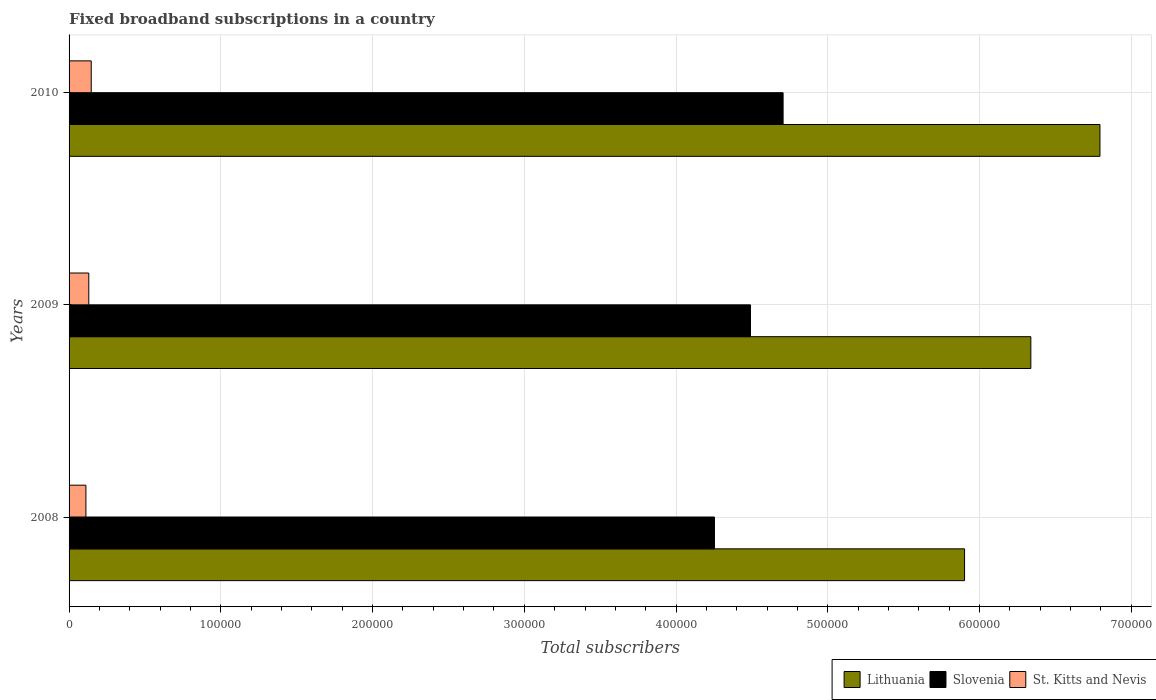How many groups of bars are there?
Your response must be concise. 3. Are the number of bars on each tick of the Y-axis equal?
Provide a short and direct response. Yes. How many bars are there on the 1st tick from the top?
Provide a short and direct response. 3. What is the label of the 1st group of bars from the top?
Provide a short and direct response. 2010. In how many cases, is the number of bars for a given year not equal to the number of legend labels?
Make the answer very short. 0. What is the number of broadband subscriptions in St. Kitts and Nevis in 2009?
Your answer should be very brief. 1.30e+04. Across all years, what is the maximum number of broadband subscriptions in Lithuania?
Your answer should be very brief. 6.79e+05. Across all years, what is the minimum number of broadband subscriptions in Lithuania?
Offer a terse response. 5.90e+05. In which year was the number of broadband subscriptions in St. Kitts and Nevis minimum?
Offer a terse response. 2008. What is the total number of broadband subscriptions in Lithuania in the graph?
Provide a succinct answer. 1.90e+06. What is the difference between the number of broadband subscriptions in Slovenia in 2009 and that in 2010?
Provide a short and direct response. -2.15e+04. What is the difference between the number of broadband subscriptions in Lithuania in 2010 and the number of broadband subscriptions in St. Kitts and Nevis in 2008?
Give a very brief answer. 6.68e+05. What is the average number of broadband subscriptions in Lithuania per year?
Make the answer very short. 6.34e+05. In the year 2010, what is the difference between the number of broadband subscriptions in Slovenia and number of broadband subscriptions in St. Kitts and Nevis?
Offer a terse response. 4.56e+05. What is the ratio of the number of broadband subscriptions in Lithuania in 2008 to that in 2010?
Keep it short and to the point. 0.87. Is the difference between the number of broadband subscriptions in Slovenia in 2008 and 2010 greater than the difference between the number of broadband subscriptions in St. Kitts and Nevis in 2008 and 2010?
Your response must be concise. No. What is the difference between the highest and the second highest number of broadband subscriptions in Lithuania?
Provide a succinct answer. 4.55e+04. What is the difference between the highest and the lowest number of broadband subscriptions in Slovenia?
Make the answer very short. 4.52e+04. What does the 3rd bar from the top in 2008 represents?
Offer a terse response. Lithuania. What does the 1st bar from the bottom in 2008 represents?
Your answer should be very brief. Lithuania. How many years are there in the graph?
Your response must be concise. 3. Are the values on the major ticks of X-axis written in scientific E-notation?
Your answer should be compact. No. Does the graph contain grids?
Make the answer very short. Yes. What is the title of the graph?
Keep it short and to the point. Fixed broadband subscriptions in a country. Does "Somalia" appear as one of the legend labels in the graph?
Your answer should be very brief. No. What is the label or title of the X-axis?
Your answer should be very brief. Total subscribers. What is the label or title of the Y-axis?
Ensure brevity in your answer.  Years. What is the Total subscribers in Lithuania in 2008?
Provide a short and direct response. 5.90e+05. What is the Total subscribers of Slovenia in 2008?
Keep it short and to the point. 4.25e+05. What is the Total subscribers in St. Kitts and Nevis in 2008?
Give a very brief answer. 1.11e+04. What is the Total subscribers in Lithuania in 2009?
Ensure brevity in your answer.  6.34e+05. What is the Total subscribers in Slovenia in 2009?
Your response must be concise. 4.49e+05. What is the Total subscribers of St. Kitts and Nevis in 2009?
Your response must be concise. 1.30e+04. What is the Total subscribers in Lithuania in 2010?
Offer a very short reply. 6.79e+05. What is the Total subscribers in Slovenia in 2010?
Your answer should be very brief. 4.71e+05. What is the Total subscribers in St. Kitts and Nevis in 2010?
Give a very brief answer. 1.46e+04. Across all years, what is the maximum Total subscribers of Lithuania?
Your answer should be compact. 6.79e+05. Across all years, what is the maximum Total subscribers in Slovenia?
Ensure brevity in your answer.  4.71e+05. Across all years, what is the maximum Total subscribers in St. Kitts and Nevis?
Provide a short and direct response. 1.46e+04. Across all years, what is the minimum Total subscribers of Lithuania?
Ensure brevity in your answer.  5.90e+05. Across all years, what is the minimum Total subscribers in Slovenia?
Provide a succinct answer. 4.25e+05. Across all years, what is the minimum Total subscribers of St. Kitts and Nevis?
Offer a very short reply. 1.11e+04. What is the total Total subscribers of Lithuania in the graph?
Your response must be concise. 1.90e+06. What is the total Total subscribers in Slovenia in the graph?
Ensure brevity in your answer.  1.34e+06. What is the total Total subscribers of St. Kitts and Nevis in the graph?
Provide a succinct answer. 3.87e+04. What is the difference between the Total subscribers of Lithuania in 2008 and that in 2009?
Ensure brevity in your answer.  -4.37e+04. What is the difference between the Total subscribers of Slovenia in 2008 and that in 2009?
Offer a very short reply. -2.37e+04. What is the difference between the Total subscribers in St. Kitts and Nevis in 2008 and that in 2009?
Your answer should be very brief. -1896. What is the difference between the Total subscribers of Lithuania in 2008 and that in 2010?
Offer a very short reply. -8.92e+04. What is the difference between the Total subscribers in Slovenia in 2008 and that in 2010?
Give a very brief answer. -4.52e+04. What is the difference between the Total subscribers of St. Kitts and Nevis in 2008 and that in 2010?
Keep it short and to the point. -3496. What is the difference between the Total subscribers of Lithuania in 2009 and that in 2010?
Ensure brevity in your answer.  -4.55e+04. What is the difference between the Total subscribers in Slovenia in 2009 and that in 2010?
Keep it short and to the point. -2.15e+04. What is the difference between the Total subscribers in St. Kitts and Nevis in 2009 and that in 2010?
Make the answer very short. -1600. What is the difference between the Total subscribers in Lithuania in 2008 and the Total subscribers in Slovenia in 2009?
Provide a short and direct response. 1.41e+05. What is the difference between the Total subscribers of Lithuania in 2008 and the Total subscribers of St. Kitts and Nevis in 2009?
Provide a succinct answer. 5.77e+05. What is the difference between the Total subscribers in Slovenia in 2008 and the Total subscribers in St. Kitts and Nevis in 2009?
Ensure brevity in your answer.  4.12e+05. What is the difference between the Total subscribers in Lithuania in 2008 and the Total subscribers in Slovenia in 2010?
Provide a succinct answer. 1.20e+05. What is the difference between the Total subscribers of Lithuania in 2008 and the Total subscribers of St. Kitts and Nevis in 2010?
Your answer should be very brief. 5.76e+05. What is the difference between the Total subscribers in Slovenia in 2008 and the Total subscribers in St. Kitts and Nevis in 2010?
Keep it short and to the point. 4.11e+05. What is the difference between the Total subscribers of Lithuania in 2009 and the Total subscribers of Slovenia in 2010?
Your answer should be very brief. 1.63e+05. What is the difference between the Total subscribers in Lithuania in 2009 and the Total subscribers in St. Kitts and Nevis in 2010?
Keep it short and to the point. 6.19e+05. What is the difference between the Total subscribers of Slovenia in 2009 and the Total subscribers of St. Kitts and Nevis in 2010?
Give a very brief answer. 4.34e+05. What is the average Total subscribers in Lithuania per year?
Provide a succinct answer. 6.34e+05. What is the average Total subscribers in Slovenia per year?
Your response must be concise. 4.48e+05. What is the average Total subscribers of St. Kitts and Nevis per year?
Ensure brevity in your answer.  1.29e+04. In the year 2008, what is the difference between the Total subscribers in Lithuania and Total subscribers in Slovenia?
Offer a terse response. 1.65e+05. In the year 2008, what is the difference between the Total subscribers of Lithuania and Total subscribers of St. Kitts and Nevis?
Offer a terse response. 5.79e+05. In the year 2008, what is the difference between the Total subscribers of Slovenia and Total subscribers of St. Kitts and Nevis?
Offer a very short reply. 4.14e+05. In the year 2009, what is the difference between the Total subscribers of Lithuania and Total subscribers of Slovenia?
Provide a succinct answer. 1.85e+05. In the year 2009, what is the difference between the Total subscribers of Lithuania and Total subscribers of St. Kitts and Nevis?
Your answer should be very brief. 6.21e+05. In the year 2009, what is the difference between the Total subscribers of Slovenia and Total subscribers of St. Kitts and Nevis?
Provide a succinct answer. 4.36e+05. In the year 2010, what is the difference between the Total subscribers in Lithuania and Total subscribers in Slovenia?
Provide a succinct answer. 2.09e+05. In the year 2010, what is the difference between the Total subscribers in Lithuania and Total subscribers in St. Kitts and Nevis?
Make the answer very short. 6.65e+05. In the year 2010, what is the difference between the Total subscribers of Slovenia and Total subscribers of St. Kitts and Nevis?
Give a very brief answer. 4.56e+05. What is the ratio of the Total subscribers of Lithuania in 2008 to that in 2009?
Give a very brief answer. 0.93. What is the ratio of the Total subscribers of Slovenia in 2008 to that in 2009?
Give a very brief answer. 0.95. What is the ratio of the Total subscribers in St. Kitts and Nevis in 2008 to that in 2009?
Provide a short and direct response. 0.85. What is the ratio of the Total subscribers in Lithuania in 2008 to that in 2010?
Your answer should be compact. 0.87. What is the ratio of the Total subscribers in Slovenia in 2008 to that in 2010?
Your response must be concise. 0.9. What is the ratio of the Total subscribers in St. Kitts and Nevis in 2008 to that in 2010?
Give a very brief answer. 0.76. What is the ratio of the Total subscribers of Lithuania in 2009 to that in 2010?
Offer a very short reply. 0.93. What is the ratio of the Total subscribers in Slovenia in 2009 to that in 2010?
Offer a very short reply. 0.95. What is the ratio of the Total subscribers of St. Kitts and Nevis in 2009 to that in 2010?
Provide a succinct answer. 0.89. What is the difference between the highest and the second highest Total subscribers in Lithuania?
Provide a short and direct response. 4.55e+04. What is the difference between the highest and the second highest Total subscribers in Slovenia?
Offer a terse response. 2.15e+04. What is the difference between the highest and the second highest Total subscribers in St. Kitts and Nevis?
Your response must be concise. 1600. What is the difference between the highest and the lowest Total subscribers in Lithuania?
Keep it short and to the point. 8.92e+04. What is the difference between the highest and the lowest Total subscribers of Slovenia?
Make the answer very short. 4.52e+04. What is the difference between the highest and the lowest Total subscribers of St. Kitts and Nevis?
Keep it short and to the point. 3496. 